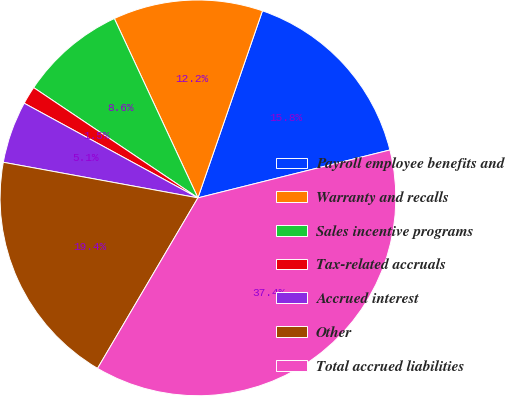Convert chart. <chart><loc_0><loc_0><loc_500><loc_500><pie_chart><fcel>Payroll employee benefits and<fcel>Warranty and recalls<fcel>Sales incentive programs<fcel>Tax-related accruals<fcel>Accrued interest<fcel>Other<fcel>Total accrued liabilities<nl><fcel>15.82%<fcel>12.23%<fcel>8.65%<fcel>1.47%<fcel>5.06%<fcel>19.41%<fcel>37.36%<nl></chart> 